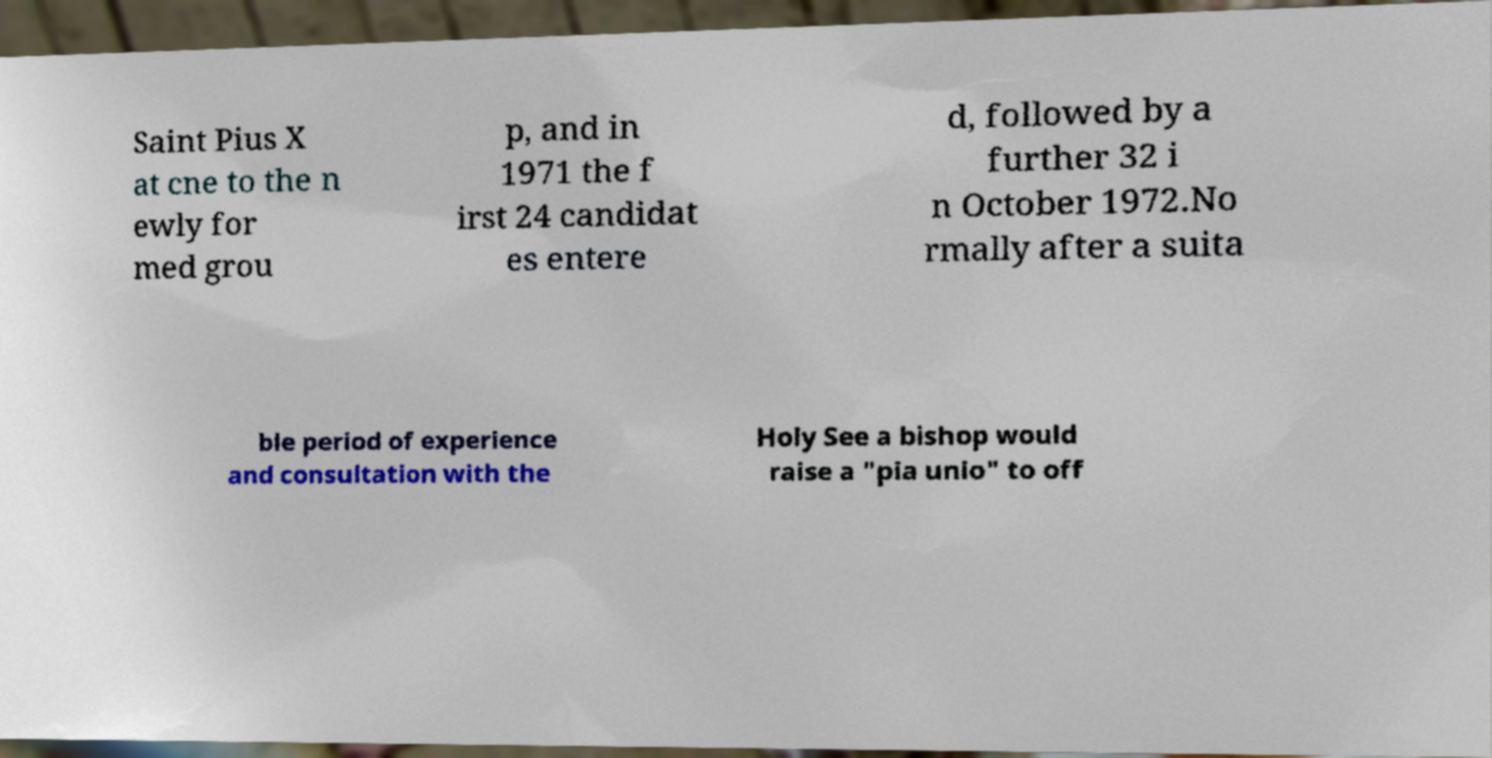Please identify and transcribe the text found in this image. Saint Pius X at cne to the n ewly for med grou p, and in 1971 the f irst 24 candidat es entere d, followed by a further 32 i n October 1972.No rmally after a suita ble period of experience and consultation with the Holy See a bishop would raise a "pia unio" to off 